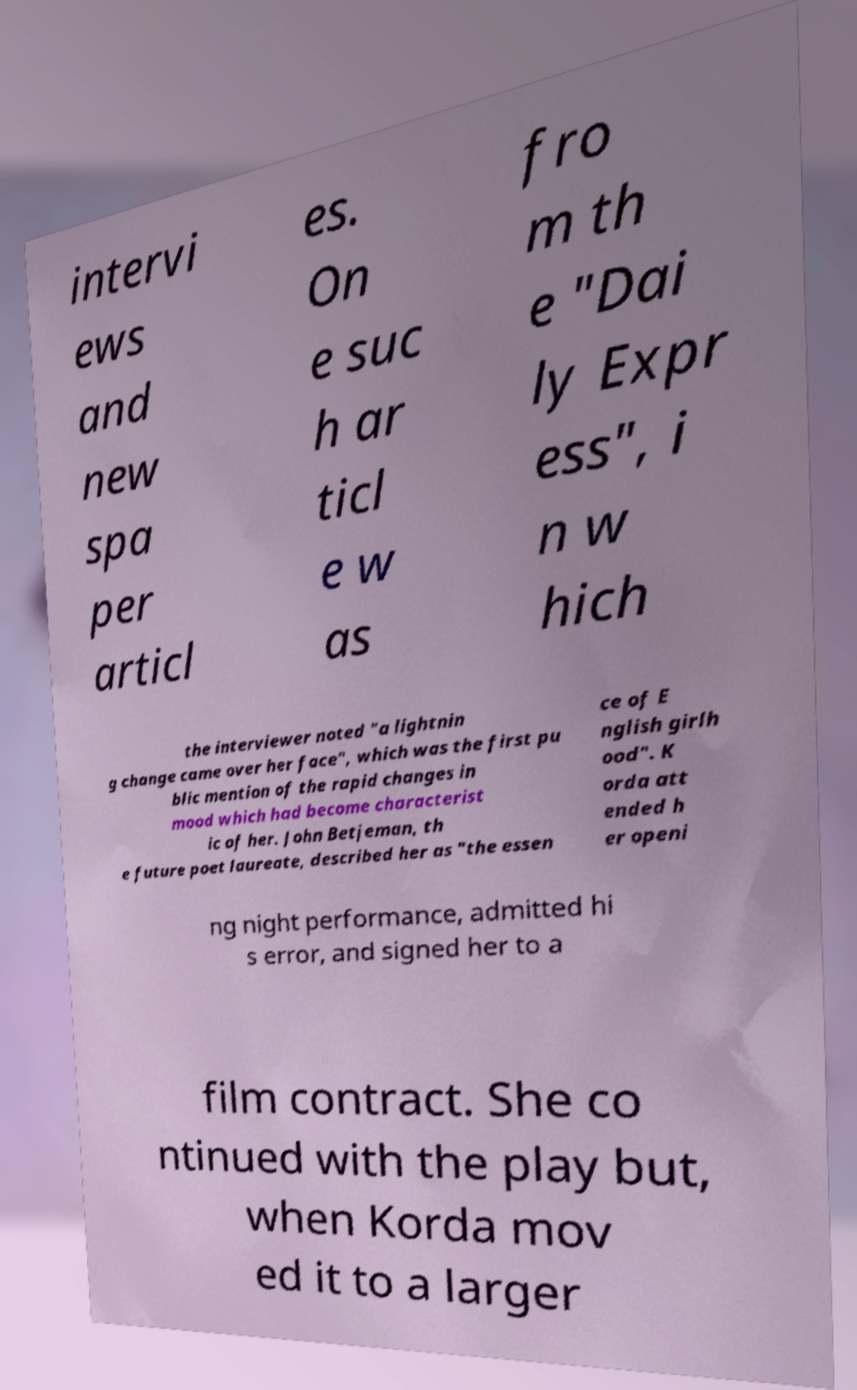I need the written content from this picture converted into text. Can you do that? intervi ews and new spa per articl es. On e suc h ar ticl e w as fro m th e "Dai ly Expr ess", i n w hich the interviewer noted "a lightnin g change came over her face", which was the first pu blic mention of the rapid changes in mood which had become characterist ic of her. John Betjeman, th e future poet laureate, described her as "the essen ce of E nglish girlh ood". K orda att ended h er openi ng night performance, admitted hi s error, and signed her to a film contract. She co ntinued with the play but, when Korda mov ed it to a larger 